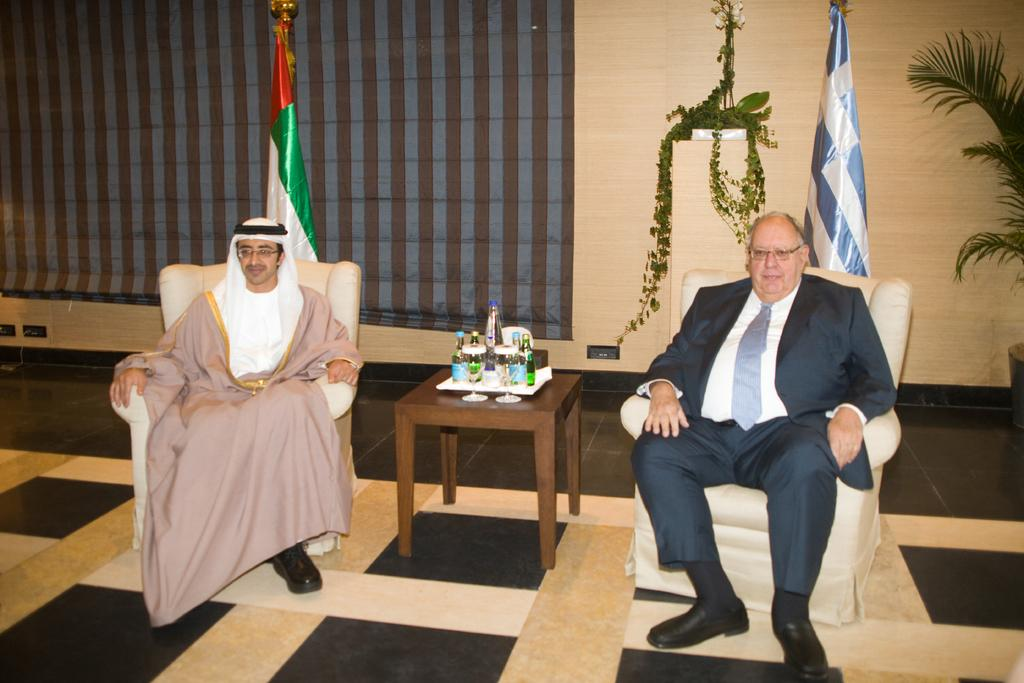What is one of the structures visible in the image? There is a wall in the image. What is attached to the wall in the image? There is a flag in the image. What type of living organism can be seen in the image? There is a plant in the image. How many people are sitting in the image? There are two people sitting on chairs in the image. What piece of furniture is present in the image? There is a table in the image. What items can be seen on the table in the image? There are bottles and glasses on the table in the image. What type of stick can be seen in the hands of the people in the image? There is no stick present in the image; the people are sitting on chairs. How does the distribution of the glasses on the table affect the observation of the flag in the image? The distribution of the glasses on the table does not affect the observation of the flag in the image, as they are separate elements in the image. 